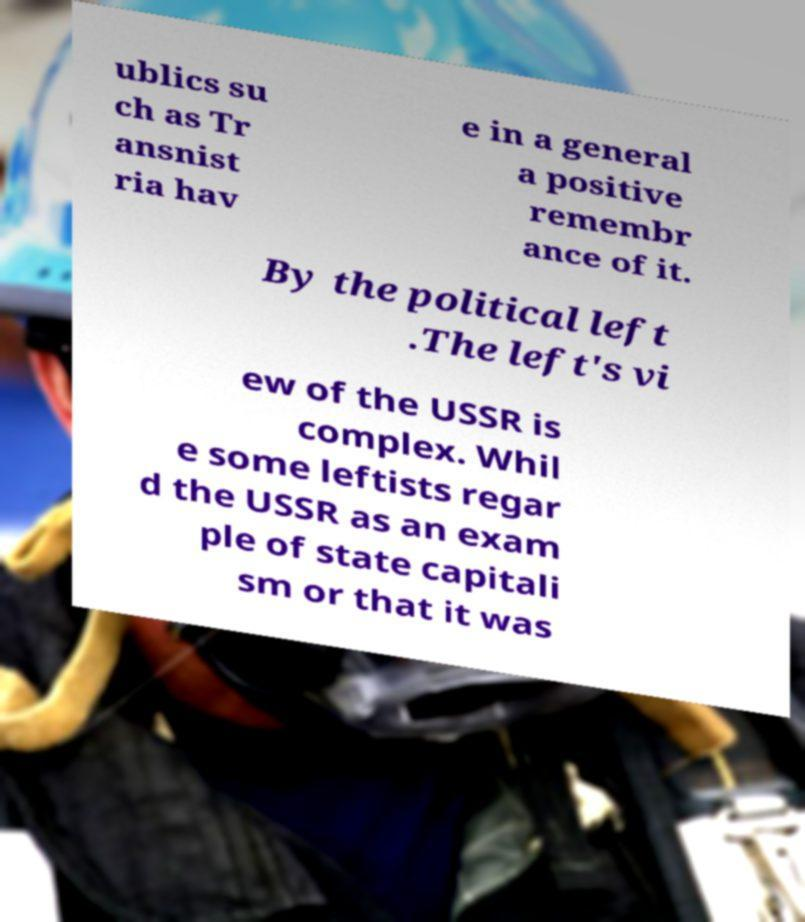For documentation purposes, I need the text within this image transcribed. Could you provide that? ublics su ch as Tr ansnist ria hav e in a general a positive remembr ance of it. By the political left .The left's vi ew of the USSR is complex. Whil e some leftists regar d the USSR as an exam ple of state capitali sm or that it was 